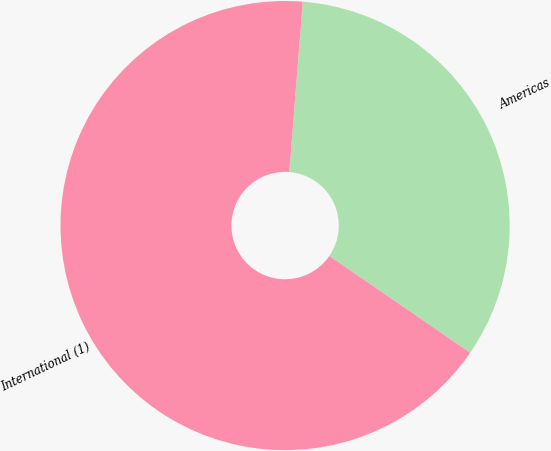<chart> <loc_0><loc_0><loc_500><loc_500><pie_chart><fcel>Americas<fcel>International (1)<nl><fcel>33.33%<fcel>66.67%<nl></chart> 